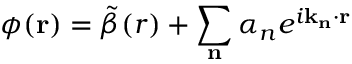<formula> <loc_0><loc_0><loc_500><loc_500>\phi ( r ) = \tilde { \beta } ( r ) + \sum _ { n } \alpha _ { n } e ^ { i k _ { n } \cdot r }</formula> 